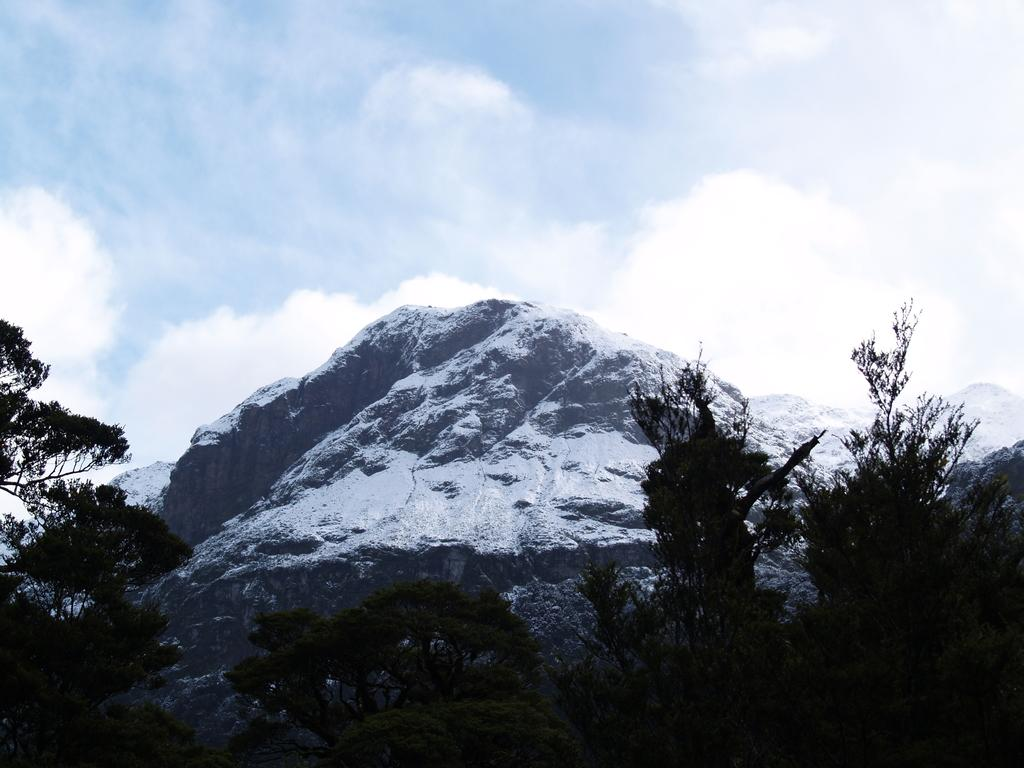What type of landscape is depicted in the image? The image appears to depict snowy mountains. What type of vegetation can be seen in the image? There are trees visible in the image. What is visible in the sky in the image? Clouds are present in the sky in the image. What type of feather can be seen falling from the sky in the image? There is no feather visible falling from the sky in the image. 